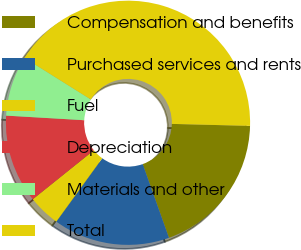<chart> <loc_0><loc_0><loc_500><loc_500><pie_chart><fcel>Compensation and benefits<fcel>Purchased services and rents<fcel>Fuel<fcel>Depreciation<fcel>Materials and other<fcel>Total<nl><fcel>19.15%<fcel>15.43%<fcel>4.25%<fcel>11.7%<fcel>7.98%<fcel>41.5%<nl></chart> 